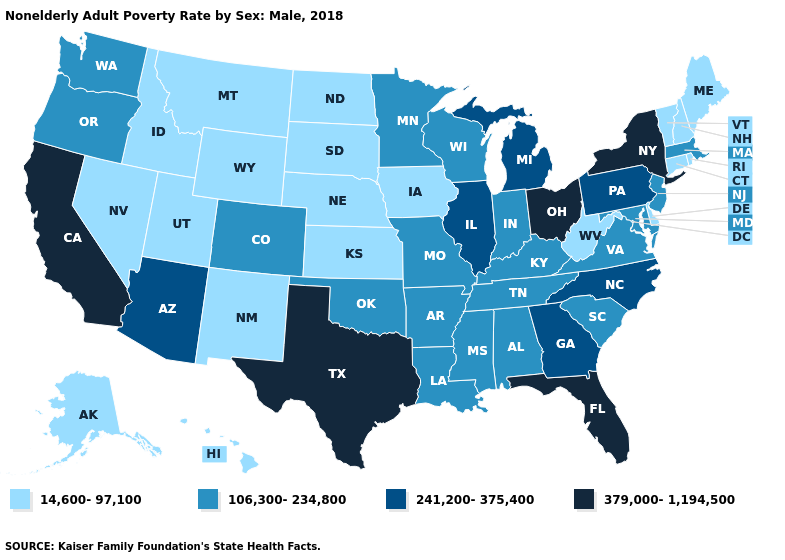Name the states that have a value in the range 379,000-1,194,500?
Short answer required. California, Florida, New York, Ohio, Texas. What is the highest value in the MidWest ?
Quick response, please. 379,000-1,194,500. What is the value of Washington?
Keep it brief. 106,300-234,800. What is the lowest value in the USA?
Answer briefly. 14,600-97,100. Among the states that border New Mexico , does Utah have the lowest value?
Answer briefly. Yes. Is the legend a continuous bar?
Short answer required. No. Does Florida have a higher value than Massachusetts?
Quick response, please. Yes. Name the states that have a value in the range 241,200-375,400?
Short answer required. Arizona, Georgia, Illinois, Michigan, North Carolina, Pennsylvania. Among the states that border Massachusetts , does New York have the lowest value?
Give a very brief answer. No. Does Wisconsin have the lowest value in the MidWest?
Be succinct. No. How many symbols are there in the legend?
Be succinct. 4. Name the states that have a value in the range 106,300-234,800?
Short answer required. Alabama, Arkansas, Colorado, Indiana, Kentucky, Louisiana, Maryland, Massachusetts, Minnesota, Mississippi, Missouri, New Jersey, Oklahoma, Oregon, South Carolina, Tennessee, Virginia, Washington, Wisconsin. Among the states that border South Dakota , does North Dakota have the lowest value?
Short answer required. Yes. Does Louisiana have a higher value than Mississippi?
Give a very brief answer. No. 